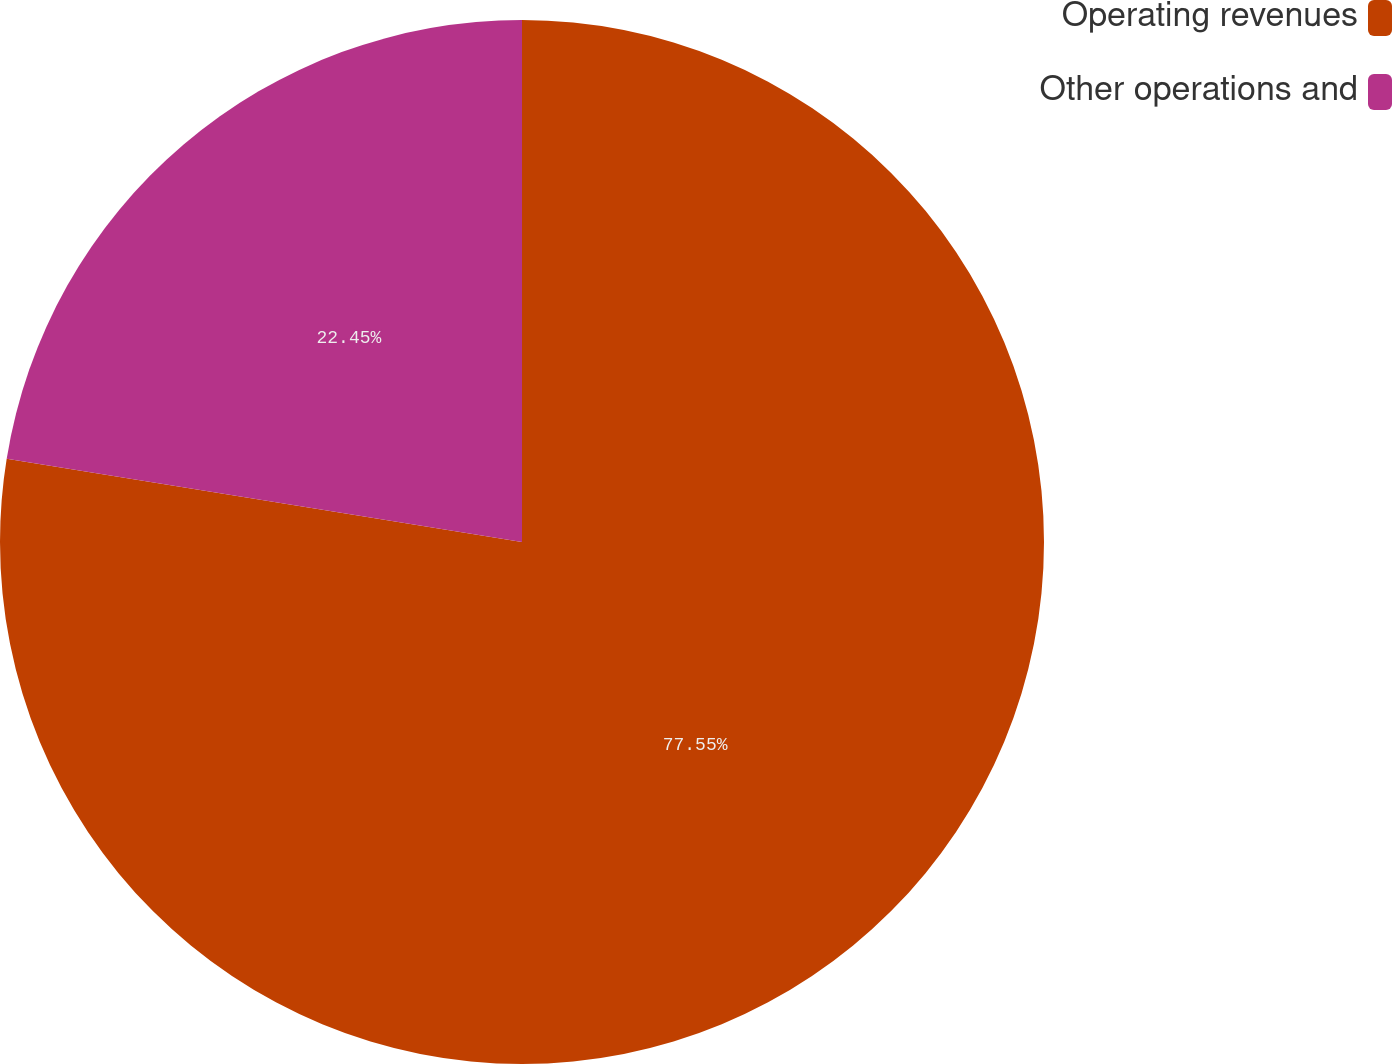Convert chart to OTSL. <chart><loc_0><loc_0><loc_500><loc_500><pie_chart><fcel>Operating revenues<fcel>Other operations and<nl><fcel>77.55%<fcel>22.45%<nl></chart> 